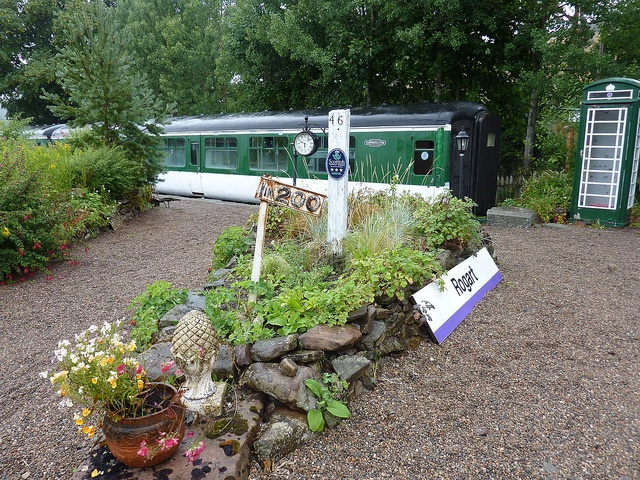Describe the objects in this image and their specific colors. I can see train in gray, white, black, and teal tones, potted plant in gray, maroon, olive, and black tones, and clock in gray, lightgray, and darkgray tones in this image. 